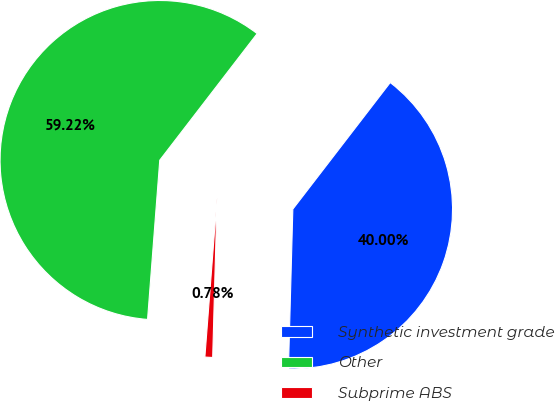Convert chart to OTSL. <chart><loc_0><loc_0><loc_500><loc_500><pie_chart><fcel>Synthetic investment grade<fcel>Other<fcel>Subprime ABS<nl><fcel>40.0%<fcel>59.22%<fcel>0.78%<nl></chart> 